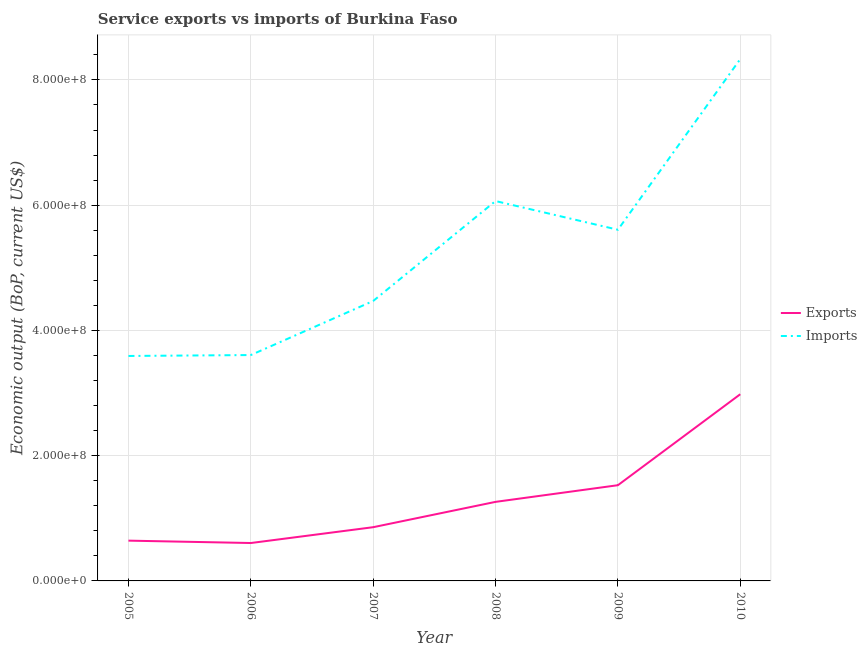How many different coloured lines are there?
Keep it short and to the point. 2. Does the line corresponding to amount of service imports intersect with the line corresponding to amount of service exports?
Keep it short and to the point. No. Is the number of lines equal to the number of legend labels?
Your answer should be compact. Yes. What is the amount of service imports in 2007?
Provide a succinct answer. 4.47e+08. Across all years, what is the maximum amount of service exports?
Provide a succinct answer. 2.98e+08. Across all years, what is the minimum amount of service exports?
Keep it short and to the point. 6.05e+07. In which year was the amount of service imports minimum?
Ensure brevity in your answer.  2005. What is the total amount of service exports in the graph?
Give a very brief answer. 7.88e+08. What is the difference between the amount of service exports in 2007 and that in 2008?
Ensure brevity in your answer.  -4.04e+07. What is the difference between the amount of service imports in 2006 and the amount of service exports in 2009?
Your answer should be very brief. 2.08e+08. What is the average amount of service exports per year?
Your answer should be very brief. 1.31e+08. In the year 2007, what is the difference between the amount of service imports and amount of service exports?
Ensure brevity in your answer.  3.61e+08. What is the ratio of the amount of service exports in 2005 to that in 2009?
Your response must be concise. 0.42. Is the difference between the amount of service imports in 2006 and 2010 greater than the difference between the amount of service exports in 2006 and 2010?
Your answer should be very brief. No. What is the difference between the highest and the second highest amount of service exports?
Make the answer very short. 1.45e+08. What is the difference between the highest and the lowest amount of service exports?
Offer a very short reply. 2.38e+08. Is the sum of the amount of service exports in 2005 and 2010 greater than the maximum amount of service imports across all years?
Offer a very short reply. No. Does the amount of service exports monotonically increase over the years?
Give a very brief answer. No. Is the amount of service imports strictly greater than the amount of service exports over the years?
Provide a succinct answer. Yes. What is the difference between two consecutive major ticks on the Y-axis?
Your answer should be compact. 2.00e+08. Does the graph contain grids?
Provide a succinct answer. Yes. Where does the legend appear in the graph?
Offer a terse response. Center right. How many legend labels are there?
Keep it short and to the point. 2. How are the legend labels stacked?
Make the answer very short. Vertical. What is the title of the graph?
Your answer should be compact. Service exports vs imports of Burkina Faso. Does "Excluding technical cooperation" appear as one of the legend labels in the graph?
Ensure brevity in your answer.  No. What is the label or title of the X-axis?
Make the answer very short. Year. What is the label or title of the Y-axis?
Provide a succinct answer. Economic output (BoP, current US$). What is the Economic output (BoP, current US$) in Exports in 2005?
Provide a short and direct response. 6.43e+07. What is the Economic output (BoP, current US$) in Imports in 2005?
Offer a terse response. 3.59e+08. What is the Economic output (BoP, current US$) of Exports in 2006?
Keep it short and to the point. 6.05e+07. What is the Economic output (BoP, current US$) in Imports in 2006?
Offer a very short reply. 3.61e+08. What is the Economic output (BoP, current US$) of Exports in 2007?
Your response must be concise. 8.58e+07. What is the Economic output (BoP, current US$) of Imports in 2007?
Give a very brief answer. 4.47e+08. What is the Economic output (BoP, current US$) of Exports in 2008?
Make the answer very short. 1.26e+08. What is the Economic output (BoP, current US$) in Imports in 2008?
Provide a succinct answer. 6.07e+08. What is the Economic output (BoP, current US$) of Exports in 2009?
Keep it short and to the point. 1.53e+08. What is the Economic output (BoP, current US$) of Imports in 2009?
Offer a terse response. 5.61e+08. What is the Economic output (BoP, current US$) in Exports in 2010?
Give a very brief answer. 2.98e+08. What is the Economic output (BoP, current US$) of Imports in 2010?
Provide a short and direct response. 8.33e+08. Across all years, what is the maximum Economic output (BoP, current US$) in Exports?
Give a very brief answer. 2.98e+08. Across all years, what is the maximum Economic output (BoP, current US$) in Imports?
Give a very brief answer. 8.33e+08. Across all years, what is the minimum Economic output (BoP, current US$) in Exports?
Make the answer very short. 6.05e+07. Across all years, what is the minimum Economic output (BoP, current US$) of Imports?
Provide a short and direct response. 3.59e+08. What is the total Economic output (BoP, current US$) in Exports in the graph?
Give a very brief answer. 7.88e+08. What is the total Economic output (BoP, current US$) in Imports in the graph?
Provide a short and direct response. 3.17e+09. What is the difference between the Economic output (BoP, current US$) in Exports in 2005 and that in 2006?
Keep it short and to the point. 3.81e+06. What is the difference between the Economic output (BoP, current US$) of Imports in 2005 and that in 2006?
Provide a short and direct response. -1.47e+06. What is the difference between the Economic output (BoP, current US$) of Exports in 2005 and that in 2007?
Keep it short and to the point. -2.15e+07. What is the difference between the Economic output (BoP, current US$) of Imports in 2005 and that in 2007?
Keep it short and to the point. -8.78e+07. What is the difference between the Economic output (BoP, current US$) in Exports in 2005 and that in 2008?
Offer a very short reply. -6.19e+07. What is the difference between the Economic output (BoP, current US$) in Imports in 2005 and that in 2008?
Give a very brief answer. -2.47e+08. What is the difference between the Economic output (BoP, current US$) in Exports in 2005 and that in 2009?
Your response must be concise. -8.85e+07. What is the difference between the Economic output (BoP, current US$) of Imports in 2005 and that in 2009?
Your answer should be compact. -2.02e+08. What is the difference between the Economic output (BoP, current US$) of Exports in 2005 and that in 2010?
Make the answer very short. -2.34e+08. What is the difference between the Economic output (BoP, current US$) in Imports in 2005 and that in 2010?
Ensure brevity in your answer.  -4.74e+08. What is the difference between the Economic output (BoP, current US$) of Exports in 2006 and that in 2007?
Provide a succinct answer. -2.53e+07. What is the difference between the Economic output (BoP, current US$) in Imports in 2006 and that in 2007?
Your answer should be very brief. -8.63e+07. What is the difference between the Economic output (BoP, current US$) of Exports in 2006 and that in 2008?
Give a very brief answer. -6.57e+07. What is the difference between the Economic output (BoP, current US$) of Imports in 2006 and that in 2008?
Your answer should be very brief. -2.46e+08. What is the difference between the Economic output (BoP, current US$) of Exports in 2006 and that in 2009?
Your answer should be compact. -9.23e+07. What is the difference between the Economic output (BoP, current US$) of Imports in 2006 and that in 2009?
Your answer should be very brief. -2.00e+08. What is the difference between the Economic output (BoP, current US$) of Exports in 2006 and that in 2010?
Offer a terse response. -2.38e+08. What is the difference between the Economic output (BoP, current US$) in Imports in 2006 and that in 2010?
Ensure brevity in your answer.  -4.73e+08. What is the difference between the Economic output (BoP, current US$) of Exports in 2007 and that in 2008?
Offer a terse response. -4.04e+07. What is the difference between the Economic output (BoP, current US$) in Imports in 2007 and that in 2008?
Your answer should be compact. -1.60e+08. What is the difference between the Economic output (BoP, current US$) of Exports in 2007 and that in 2009?
Ensure brevity in your answer.  -6.71e+07. What is the difference between the Economic output (BoP, current US$) of Imports in 2007 and that in 2009?
Make the answer very short. -1.14e+08. What is the difference between the Economic output (BoP, current US$) of Exports in 2007 and that in 2010?
Your response must be concise. -2.12e+08. What is the difference between the Economic output (BoP, current US$) in Imports in 2007 and that in 2010?
Offer a terse response. -3.86e+08. What is the difference between the Economic output (BoP, current US$) of Exports in 2008 and that in 2009?
Keep it short and to the point. -2.66e+07. What is the difference between the Economic output (BoP, current US$) of Imports in 2008 and that in 2009?
Offer a very short reply. 4.58e+07. What is the difference between the Economic output (BoP, current US$) of Exports in 2008 and that in 2010?
Offer a very short reply. -1.72e+08. What is the difference between the Economic output (BoP, current US$) in Imports in 2008 and that in 2010?
Provide a short and direct response. -2.27e+08. What is the difference between the Economic output (BoP, current US$) of Exports in 2009 and that in 2010?
Your response must be concise. -1.45e+08. What is the difference between the Economic output (BoP, current US$) in Imports in 2009 and that in 2010?
Give a very brief answer. -2.73e+08. What is the difference between the Economic output (BoP, current US$) of Exports in 2005 and the Economic output (BoP, current US$) of Imports in 2006?
Keep it short and to the point. -2.96e+08. What is the difference between the Economic output (BoP, current US$) of Exports in 2005 and the Economic output (BoP, current US$) of Imports in 2007?
Your response must be concise. -3.83e+08. What is the difference between the Economic output (BoP, current US$) in Exports in 2005 and the Economic output (BoP, current US$) in Imports in 2008?
Provide a succinct answer. -5.42e+08. What is the difference between the Economic output (BoP, current US$) in Exports in 2005 and the Economic output (BoP, current US$) in Imports in 2009?
Make the answer very short. -4.96e+08. What is the difference between the Economic output (BoP, current US$) of Exports in 2005 and the Economic output (BoP, current US$) of Imports in 2010?
Keep it short and to the point. -7.69e+08. What is the difference between the Economic output (BoP, current US$) in Exports in 2006 and the Economic output (BoP, current US$) in Imports in 2007?
Give a very brief answer. -3.87e+08. What is the difference between the Economic output (BoP, current US$) of Exports in 2006 and the Economic output (BoP, current US$) of Imports in 2008?
Your response must be concise. -5.46e+08. What is the difference between the Economic output (BoP, current US$) in Exports in 2006 and the Economic output (BoP, current US$) in Imports in 2009?
Your response must be concise. -5.00e+08. What is the difference between the Economic output (BoP, current US$) of Exports in 2006 and the Economic output (BoP, current US$) of Imports in 2010?
Make the answer very short. -7.73e+08. What is the difference between the Economic output (BoP, current US$) in Exports in 2007 and the Economic output (BoP, current US$) in Imports in 2008?
Your response must be concise. -5.21e+08. What is the difference between the Economic output (BoP, current US$) of Exports in 2007 and the Economic output (BoP, current US$) of Imports in 2009?
Your answer should be compact. -4.75e+08. What is the difference between the Economic output (BoP, current US$) in Exports in 2007 and the Economic output (BoP, current US$) in Imports in 2010?
Keep it short and to the point. -7.48e+08. What is the difference between the Economic output (BoP, current US$) of Exports in 2008 and the Economic output (BoP, current US$) of Imports in 2009?
Your answer should be very brief. -4.35e+08. What is the difference between the Economic output (BoP, current US$) in Exports in 2008 and the Economic output (BoP, current US$) in Imports in 2010?
Provide a short and direct response. -7.07e+08. What is the difference between the Economic output (BoP, current US$) in Exports in 2009 and the Economic output (BoP, current US$) in Imports in 2010?
Your answer should be very brief. -6.80e+08. What is the average Economic output (BoP, current US$) of Exports per year?
Your answer should be compact. 1.31e+08. What is the average Economic output (BoP, current US$) in Imports per year?
Offer a very short reply. 5.28e+08. In the year 2005, what is the difference between the Economic output (BoP, current US$) in Exports and Economic output (BoP, current US$) in Imports?
Give a very brief answer. -2.95e+08. In the year 2006, what is the difference between the Economic output (BoP, current US$) in Exports and Economic output (BoP, current US$) in Imports?
Provide a short and direct response. -3.00e+08. In the year 2007, what is the difference between the Economic output (BoP, current US$) of Exports and Economic output (BoP, current US$) of Imports?
Keep it short and to the point. -3.61e+08. In the year 2008, what is the difference between the Economic output (BoP, current US$) in Exports and Economic output (BoP, current US$) in Imports?
Keep it short and to the point. -4.80e+08. In the year 2009, what is the difference between the Economic output (BoP, current US$) in Exports and Economic output (BoP, current US$) in Imports?
Provide a short and direct response. -4.08e+08. In the year 2010, what is the difference between the Economic output (BoP, current US$) in Exports and Economic output (BoP, current US$) in Imports?
Give a very brief answer. -5.35e+08. What is the ratio of the Economic output (BoP, current US$) of Exports in 2005 to that in 2006?
Keep it short and to the point. 1.06. What is the ratio of the Economic output (BoP, current US$) in Imports in 2005 to that in 2006?
Your response must be concise. 1. What is the ratio of the Economic output (BoP, current US$) in Exports in 2005 to that in 2007?
Your answer should be compact. 0.75. What is the ratio of the Economic output (BoP, current US$) in Imports in 2005 to that in 2007?
Make the answer very short. 0.8. What is the ratio of the Economic output (BoP, current US$) of Exports in 2005 to that in 2008?
Offer a very short reply. 0.51. What is the ratio of the Economic output (BoP, current US$) in Imports in 2005 to that in 2008?
Your answer should be very brief. 0.59. What is the ratio of the Economic output (BoP, current US$) of Exports in 2005 to that in 2009?
Provide a short and direct response. 0.42. What is the ratio of the Economic output (BoP, current US$) of Imports in 2005 to that in 2009?
Keep it short and to the point. 0.64. What is the ratio of the Economic output (BoP, current US$) in Exports in 2005 to that in 2010?
Your response must be concise. 0.22. What is the ratio of the Economic output (BoP, current US$) in Imports in 2005 to that in 2010?
Offer a very short reply. 0.43. What is the ratio of the Economic output (BoP, current US$) in Exports in 2006 to that in 2007?
Provide a short and direct response. 0.71. What is the ratio of the Economic output (BoP, current US$) of Imports in 2006 to that in 2007?
Keep it short and to the point. 0.81. What is the ratio of the Economic output (BoP, current US$) of Exports in 2006 to that in 2008?
Offer a terse response. 0.48. What is the ratio of the Economic output (BoP, current US$) in Imports in 2006 to that in 2008?
Make the answer very short. 0.59. What is the ratio of the Economic output (BoP, current US$) in Exports in 2006 to that in 2009?
Offer a terse response. 0.4. What is the ratio of the Economic output (BoP, current US$) in Imports in 2006 to that in 2009?
Offer a terse response. 0.64. What is the ratio of the Economic output (BoP, current US$) of Exports in 2006 to that in 2010?
Keep it short and to the point. 0.2. What is the ratio of the Economic output (BoP, current US$) of Imports in 2006 to that in 2010?
Make the answer very short. 0.43. What is the ratio of the Economic output (BoP, current US$) of Exports in 2007 to that in 2008?
Keep it short and to the point. 0.68. What is the ratio of the Economic output (BoP, current US$) of Imports in 2007 to that in 2008?
Your answer should be compact. 0.74. What is the ratio of the Economic output (BoP, current US$) of Exports in 2007 to that in 2009?
Provide a succinct answer. 0.56. What is the ratio of the Economic output (BoP, current US$) in Imports in 2007 to that in 2009?
Your answer should be very brief. 0.8. What is the ratio of the Economic output (BoP, current US$) in Exports in 2007 to that in 2010?
Provide a short and direct response. 0.29. What is the ratio of the Economic output (BoP, current US$) in Imports in 2007 to that in 2010?
Give a very brief answer. 0.54. What is the ratio of the Economic output (BoP, current US$) in Exports in 2008 to that in 2009?
Your answer should be very brief. 0.83. What is the ratio of the Economic output (BoP, current US$) of Imports in 2008 to that in 2009?
Ensure brevity in your answer.  1.08. What is the ratio of the Economic output (BoP, current US$) in Exports in 2008 to that in 2010?
Your answer should be compact. 0.42. What is the ratio of the Economic output (BoP, current US$) in Imports in 2008 to that in 2010?
Your answer should be compact. 0.73. What is the ratio of the Economic output (BoP, current US$) of Exports in 2009 to that in 2010?
Provide a succinct answer. 0.51. What is the ratio of the Economic output (BoP, current US$) of Imports in 2009 to that in 2010?
Your response must be concise. 0.67. What is the difference between the highest and the second highest Economic output (BoP, current US$) of Exports?
Offer a terse response. 1.45e+08. What is the difference between the highest and the second highest Economic output (BoP, current US$) of Imports?
Offer a terse response. 2.27e+08. What is the difference between the highest and the lowest Economic output (BoP, current US$) in Exports?
Your response must be concise. 2.38e+08. What is the difference between the highest and the lowest Economic output (BoP, current US$) in Imports?
Keep it short and to the point. 4.74e+08. 